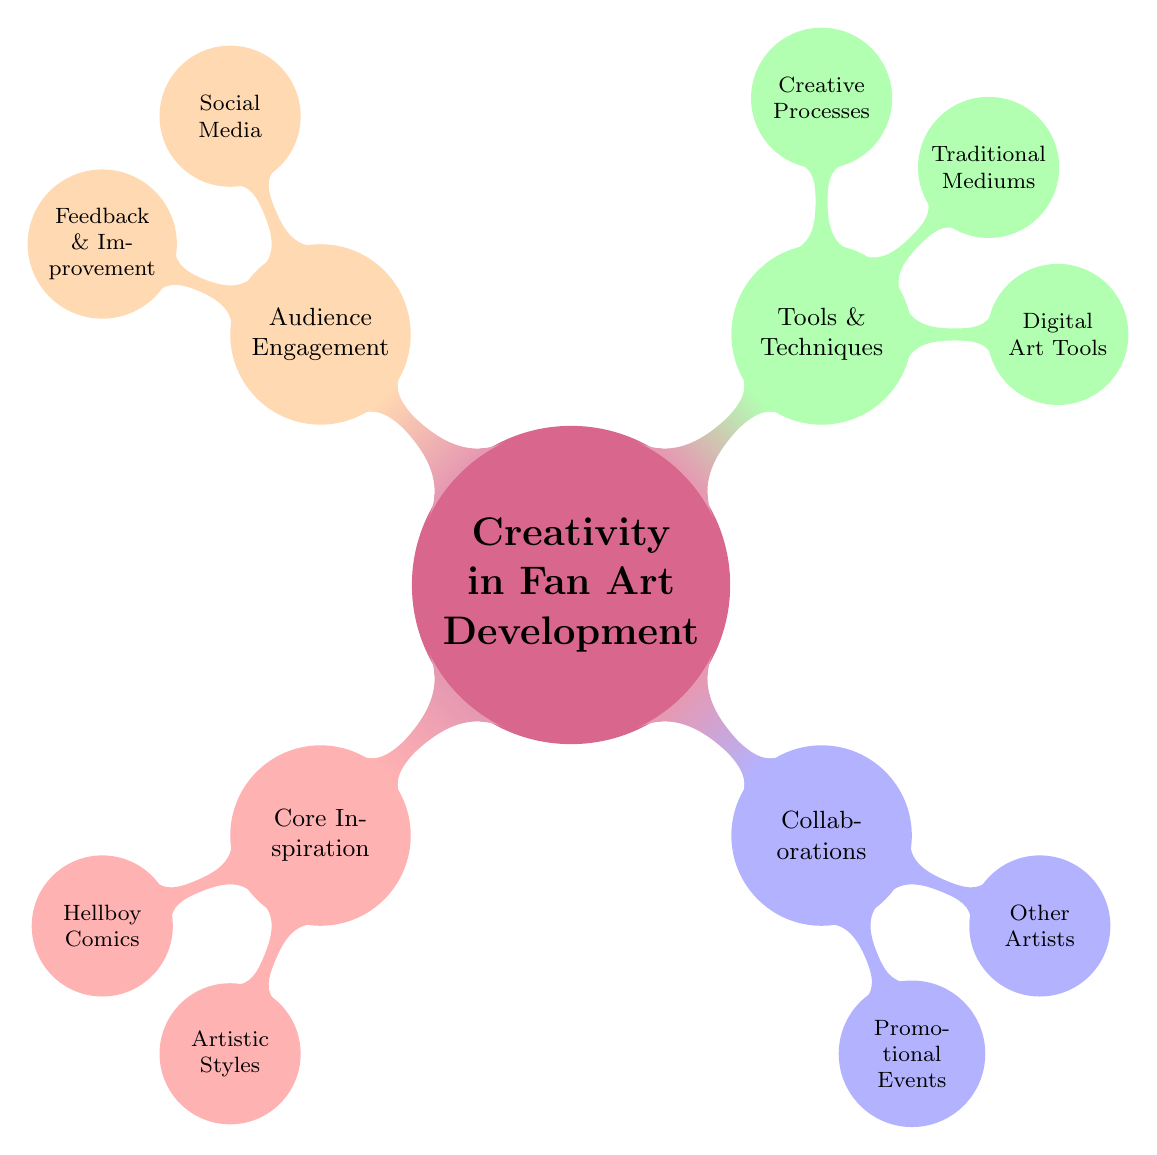What is the core theme of this mind map? The main topic at the center of the diagram is "Creativity in Fan Art Development." It represents the overall concept being explored.
Answer: Creativity in Fan Art Development How many main branches are there in the diagram? The diagram consists of four main branches, each branching out from the central theme. They are Core Inspiration, Collaborations, Tools & Techniques, and Audience Engagement.
Answer: 4 Which node is associated with the original Hellboy series? The node that contains information about the original Hellboy series is under "Core Inspiration" and is labeled "Primary Source."
Answer: Primary Source What techniques are highlighted under "Digital Art Tools"? Under "Digital Art Tools," the techniques listed include "Software" and "Hardware." These are categorized as digital tools used for fan art development.
Answer: Software, Hardware What type of events are associated with "Collaborations"? The "Collaborations" branch has two categories: "Promotional Events" and "Other Artists." These events facilitate collaboration among fan artists.
Answer: Promotional Events, Other Artists Which social media platform is mentioned for professional showcasing? The platform specified for professional showcasing is "ArtStation," which falls under the "Social Media" node in the "Audience Engagement" branch.
Answer: ArtStation How are constructive criticisms received according to the diagram? Constructive criticisms are received through the node "Critique Groups," which is listed under the "Feedback & Improvement" section of the "Audience Engagement" branch.
Answer: Critique Groups What is one traditional medium mentioned in the diagram? "Inking" is one traditional medium highlighted in the "Traditional Mediums" section, indicating the various techniques available for fan art.
Answer: Inking What is the purpose of "ComicsCon" in the context of this mind map? "ComicCon" is categorized under "Promotional Events," indicating its role in enhancing fan engagement and providing feedback opportunities.
Answer: Fan Engagement and Feedback Which artist's techniques are notably recognized in the "Artistic Styles" section? The techniques of "Mike Mignola" are recognized in the "Artistic Styles" branch, emphasizing the influence of this artist in fan art creation.
Answer: Mike Mignola 